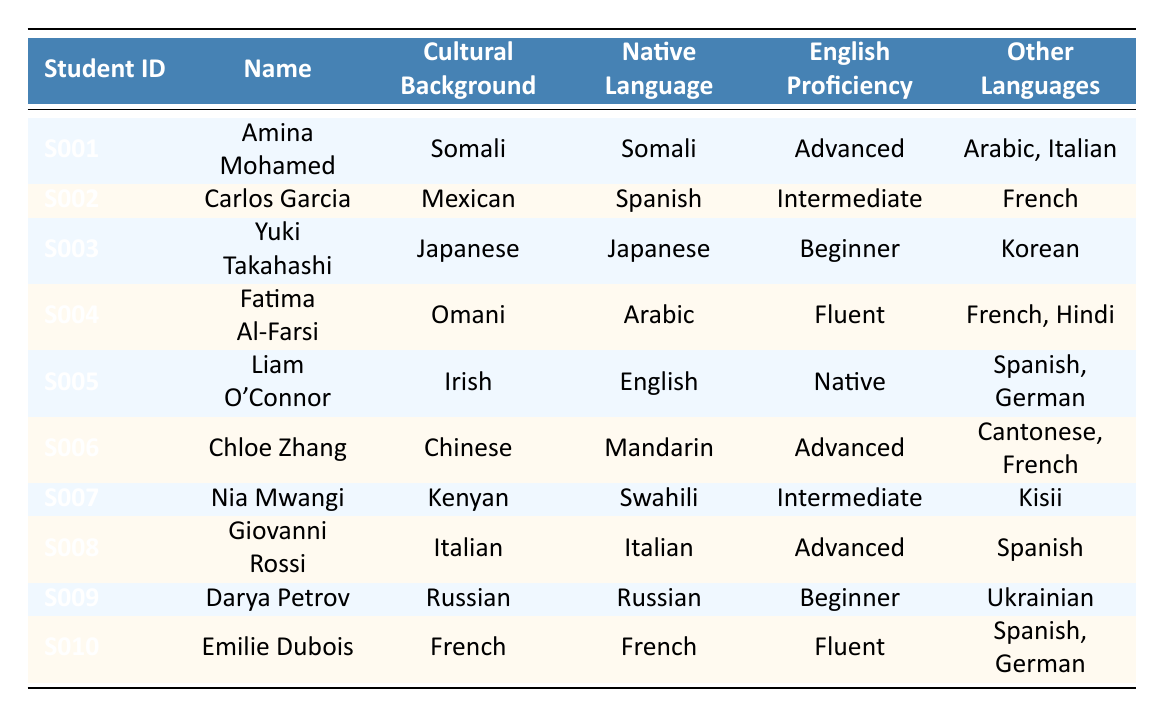What is the native language of Chloe Zhang? Chloe Zhang's entry in the table lists her native language as Mandarin.
Answer: Mandarin How many students have an advanced level of English proficiency? In the table, Amina Mohamed, Chloe Zhang, and Giovanni Rossi are the three students listed with an advanced level of English proficiency.
Answer: 3 Who is the student from Kenya? The table shows that Nia Mwangi is the student with a cultural background of Kenyan.
Answer: Nia Mwangi Are there any students whose native language is Arabic? The table lists Fatima Al-Farsi as the only student whose native language is Arabic.
Answer: Yes What is the English proficiency level of Darya Petrov? According to the table, Darya Petrov has a beginner level of English proficiency.
Answer: Beginner How many languages does Liam O'Connor speak altogether? Liam O'Connor's native language is English and he speaks Spanish and German, totaling three languages.
Answer: 3 Which cultural background has the highest representation in the table? Each cultural background has one representative in the table, so there is no single highest representation.
Answer: None What percentage of students speak French in addition to English? Four students (Fatima Al-Farsi, Chloe Zhang, Emilie Dubois, and Carlos Garcia) speak French among the ten students. Therefore, the percentage is (4/10)*100 = 40%.
Answer: 40% Is there a student with both advanced English proficiency and a native language of a non-European language? Amina Mohamed and Chloe Zhang are both advanced and have native languages (Somali and Mandarin) that are not European.
Answer: Yes Which student has the combination of the highest level of English proficiency and the native language of a European language? Liam O'Connor is a native English speaker with a native language of English and has a native level of proficiency.
Answer: Liam O'Connor What is the average English proficiency level among the students listed, considering Beginner as 1, Intermediate as 2, Advanced as 3, Fluent as 4, and Native as 5? The English proficiency levels correspond to: Amina (3), Carlos (2), Yuki (1), Fatima (4), Liam (5), Chloe (3), Nia (2), Giovanni (3), Darya (1), Emilie (4). The sum is (3 + 2 + 1 + 4 + 5 + 3 + 2 + 3 + 1 + 4) = 28, and there are 10 students, so the average is 28/10 = 2.8.
Answer: 2.8 